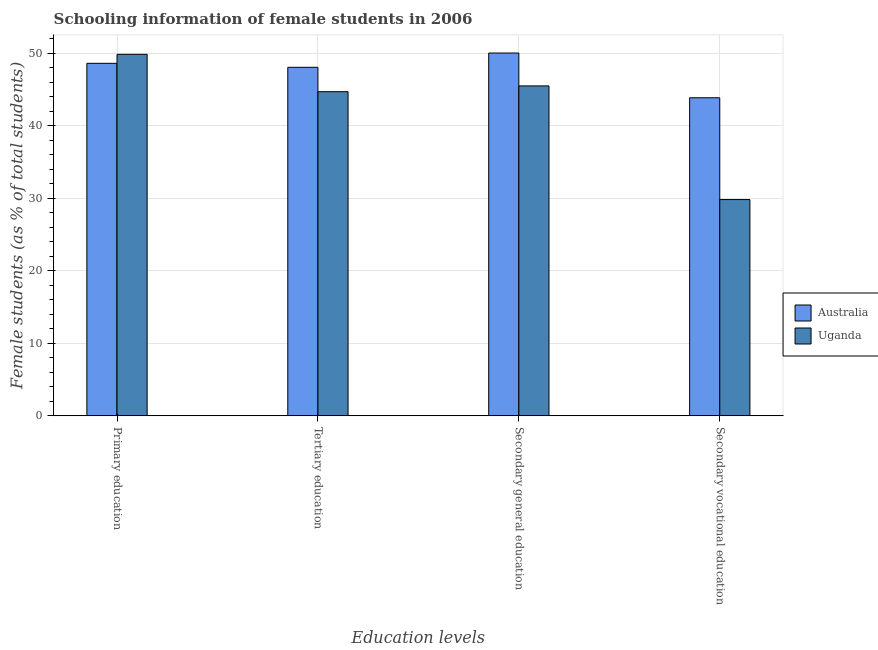How many groups of bars are there?
Offer a very short reply. 4. Are the number of bars on each tick of the X-axis equal?
Provide a short and direct response. Yes. How many bars are there on the 1st tick from the left?
Offer a very short reply. 2. What is the label of the 4th group of bars from the left?
Give a very brief answer. Secondary vocational education. What is the percentage of female students in secondary vocational education in Australia?
Offer a very short reply. 43.86. Across all countries, what is the maximum percentage of female students in primary education?
Give a very brief answer. 49.85. Across all countries, what is the minimum percentage of female students in tertiary education?
Keep it short and to the point. 44.7. In which country was the percentage of female students in primary education minimum?
Give a very brief answer. Australia. What is the total percentage of female students in tertiary education in the graph?
Make the answer very short. 92.76. What is the difference between the percentage of female students in tertiary education in Australia and that in Uganda?
Your answer should be very brief. 3.36. What is the difference between the percentage of female students in secondary education in Australia and the percentage of female students in secondary vocational education in Uganda?
Provide a short and direct response. 20.2. What is the average percentage of female students in secondary education per country?
Ensure brevity in your answer.  47.76. What is the difference between the percentage of female students in secondary vocational education and percentage of female students in primary education in Australia?
Offer a very short reply. -4.75. In how many countries, is the percentage of female students in secondary education greater than 44 %?
Provide a succinct answer. 2. What is the ratio of the percentage of female students in secondary education in Uganda to that in Australia?
Keep it short and to the point. 0.91. What is the difference between the highest and the second highest percentage of female students in secondary vocational education?
Ensure brevity in your answer.  14.03. What is the difference between the highest and the lowest percentage of female students in secondary vocational education?
Your response must be concise. 14.03. What does the 2nd bar from the left in Tertiary education represents?
Offer a very short reply. Uganda. What does the 1st bar from the right in Primary education represents?
Offer a terse response. Uganda. Is it the case that in every country, the sum of the percentage of female students in primary education and percentage of female students in tertiary education is greater than the percentage of female students in secondary education?
Your answer should be compact. Yes. How many bars are there?
Ensure brevity in your answer.  8. What is the difference between two consecutive major ticks on the Y-axis?
Offer a terse response. 10. Does the graph contain any zero values?
Offer a very short reply. No. Does the graph contain grids?
Your response must be concise. Yes. How many legend labels are there?
Offer a terse response. 2. How are the legend labels stacked?
Give a very brief answer. Vertical. What is the title of the graph?
Your answer should be very brief. Schooling information of female students in 2006. Does "Germany" appear as one of the legend labels in the graph?
Keep it short and to the point. No. What is the label or title of the X-axis?
Give a very brief answer. Education levels. What is the label or title of the Y-axis?
Your answer should be very brief. Female students (as % of total students). What is the Female students (as % of total students) of Australia in Primary education?
Ensure brevity in your answer.  48.61. What is the Female students (as % of total students) of Uganda in Primary education?
Keep it short and to the point. 49.85. What is the Female students (as % of total students) in Australia in Tertiary education?
Provide a short and direct response. 48.06. What is the Female students (as % of total students) in Uganda in Tertiary education?
Offer a very short reply. 44.7. What is the Female students (as % of total students) of Australia in Secondary general education?
Ensure brevity in your answer.  50.03. What is the Female students (as % of total students) of Uganda in Secondary general education?
Your answer should be compact. 45.5. What is the Female students (as % of total students) in Australia in Secondary vocational education?
Offer a very short reply. 43.86. What is the Female students (as % of total students) of Uganda in Secondary vocational education?
Your response must be concise. 29.83. Across all Education levels, what is the maximum Female students (as % of total students) in Australia?
Make the answer very short. 50.03. Across all Education levels, what is the maximum Female students (as % of total students) of Uganda?
Your response must be concise. 49.85. Across all Education levels, what is the minimum Female students (as % of total students) in Australia?
Provide a succinct answer. 43.86. Across all Education levels, what is the minimum Female students (as % of total students) in Uganda?
Keep it short and to the point. 29.83. What is the total Female students (as % of total students) of Australia in the graph?
Make the answer very short. 190.56. What is the total Female students (as % of total students) in Uganda in the graph?
Give a very brief answer. 169.87. What is the difference between the Female students (as % of total students) of Australia in Primary education and that in Tertiary education?
Ensure brevity in your answer.  0.55. What is the difference between the Female students (as % of total students) in Uganda in Primary education and that in Tertiary education?
Your response must be concise. 5.15. What is the difference between the Female students (as % of total students) of Australia in Primary education and that in Secondary general education?
Your response must be concise. -1.42. What is the difference between the Female students (as % of total students) of Uganda in Primary education and that in Secondary general education?
Your answer should be compact. 4.35. What is the difference between the Female students (as % of total students) of Australia in Primary education and that in Secondary vocational education?
Provide a succinct answer. 4.75. What is the difference between the Female students (as % of total students) in Uganda in Primary education and that in Secondary vocational education?
Offer a terse response. 20.02. What is the difference between the Female students (as % of total students) in Australia in Tertiary education and that in Secondary general education?
Offer a very short reply. -1.97. What is the difference between the Female students (as % of total students) in Uganda in Tertiary education and that in Secondary general education?
Provide a succinct answer. -0.8. What is the difference between the Female students (as % of total students) of Australia in Tertiary education and that in Secondary vocational education?
Keep it short and to the point. 4.2. What is the difference between the Female students (as % of total students) of Uganda in Tertiary education and that in Secondary vocational education?
Your response must be concise. 14.87. What is the difference between the Female students (as % of total students) in Australia in Secondary general education and that in Secondary vocational education?
Make the answer very short. 6.17. What is the difference between the Female students (as % of total students) of Uganda in Secondary general education and that in Secondary vocational education?
Provide a short and direct response. 15.67. What is the difference between the Female students (as % of total students) in Australia in Primary education and the Female students (as % of total students) in Uganda in Tertiary education?
Make the answer very short. 3.91. What is the difference between the Female students (as % of total students) of Australia in Primary education and the Female students (as % of total students) of Uganda in Secondary general education?
Your response must be concise. 3.11. What is the difference between the Female students (as % of total students) in Australia in Primary education and the Female students (as % of total students) in Uganda in Secondary vocational education?
Give a very brief answer. 18.78. What is the difference between the Female students (as % of total students) of Australia in Tertiary education and the Female students (as % of total students) of Uganda in Secondary general education?
Keep it short and to the point. 2.57. What is the difference between the Female students (as % of total students) of Australia in Tertiary education and the Female students (as % of total students) of Uganda in Secondary vocational education?
Provide a succinct answer. 18.24. What is the difference between the Female students (as % of total students) of Australia in Secondary general education and the Female students (as % of total students) of Uganda in Secondary vocational education?
Provide a succinct answer. 20.2. What is the average Female students (as % of total students) of Australia per Education levels?
Your answer should be compact. 47.64. What is the average Female students (as % of total students) of Uganda per Education levels?
Give a very brief answer. 42.47. What is the difference between the Female students (as % of total students) in Australia and Female students (as % of total students) in Uganda in Primary education?
Your answer should be very brief. -1.24. What is the difference between the Female students (as % of total students) in Australia and Female students (as % of total students) in Uganda in Tertiary education?
Offer a very short reply. 3.36. What is the difference between the Female students (as % of total students) of Australia and Female students (as % of total students) of Uganda in Secondary general education?
Give a very brief answer. 4.54. What is the difference between the Female students (as % of total students) of Australia and Female students (as % of total students) of Uganda in Secondary vocational education?
Give a very brief answer. 14.03. What is the ratio of the Female students (as % of total students) of Australia in Primary education to that in Tertiary education?
Keep it short and to the point. 1.01. What is the ratio of the Female students (as % of total students) of Uganda in Primary education to that in Tertiary education?
Give a very brief answer. 1.12. What is the ratio of the Female students (as % of total students) of Australia in Primary education to that in Secondary general education?
Offer a very short reply. 0.97. What is the ratio of the Female students (as % of total students) in Uganda in Primary education to that in Secondary general education?
Offer a very short reply. 1.1. What is the ratio of the Female students (as % of total students) in Australia in Primary education to that in Secondary vocational education?
Provide a succinct answer. 1.11. What is the ratio of the Female students (as % of total students) in Uganda in Primary education to that in Secondary vocational education?
Ensure brevity in your answer.  1.67. What is the ratio of the Female students (as % of total students) of Australia in Tertiary education to that in Secondary general education?
Give a very brief answer. 0.96. What is the ratio of the Female students (as % of total students) in Uganda in Tertiary education to that in Secondary general education?
Make the answer very short. 0.98. What is the ratio of the Female students (as % of total students) of Australia in Tertiary education to that in Secondary vocational education?
Keep it short and to the point. 1.1. What is the ratio of the Female students (as % of total students) in Uganda in Tertiary education to that in Secondary vocational education?
Your answer should be very brief. 1.5. What is the ratio of the Female students (as % of total students) in Australia in Secondary general education to that in Secondary vocational education?
Keep it short and to the point. 1.14. What is the ratio of the Female students (as % of total students) of Uganda in Secondary general education to that in Secondary vocational education?
Provide a short and direct response. 1.53. What is the difference between the highest and the second highest Female students (as % of total students) in Australia?
Offer a terse response. 1.42. What is the difference between the highest and the second highest Female students (as % of total students) of Uganda?
Your response must be concise. 4.35. What is the difference between the highest and the lowest Female students (as % of total students) in Australia?
Your response must be concise. 6.17. What is the difference between the highest and the lowest Female students (as % of total students) in Uganda?
Provide a short and direct response. 20.02. 